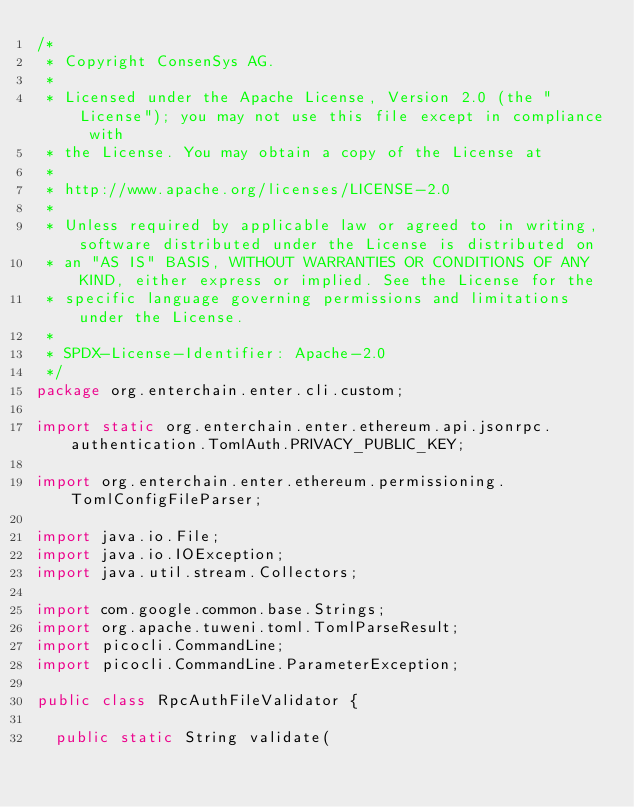<code> <loc_0><loc_0><loc_500><loc_500><_Java_>/*
 * Copyright ConsenSys AG.
 *
 * Licensed under the Apache License, Version 2.0 (the "License"); you may not use this file except in compliance with
 * the License. You may obtain a copy of the License at
 *
 * http://www.apache.org/licenses/LICENSE-2.0
 *
 * Unless required by applicable law or agreed to in writing, software distributed under the License is distributed on
 * an "AS IS" BASIS, WITHOUT WARRANTIES OR CONDITIONS OF ANY KIND, either express or implied. See the License for the
 * specific language governing permissions and limitations under the License.
 *
 * SPDX-License-Identifier: Apache-2.0
 */
package org.enterchain.enter.cli.custom;

import static org.enterchain.enter.ethereum.api.jsonrpc.authentication.TomlAuth.PRIVACY_PUBLIC_KEY;

import org.enterchain.enter.ethereum.permissioning.TomlConfigFileParser;

import java.io.File;
import java.io.IOException;
import java.util.stream.Collectors;

import com.google.common.base.Strings;
import org.apache.tuweni.toml.TomlParseResult;
import picocli.CommandLine;
import picocli.CommandLine.ParameterException;

public class RpcAuthFileValidator {

  public static String validate(</code> 